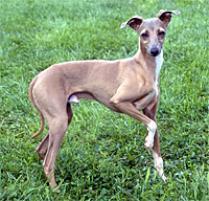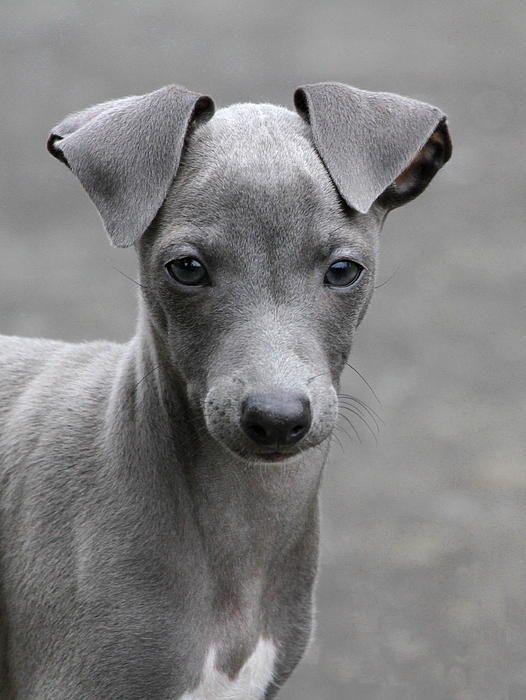The first image is the image on the left, the second image is the image on the right. Given the left and right images, does the statement "The full body of a dog facing right is on the left image." hold true? Answer yes or no. Yes. 